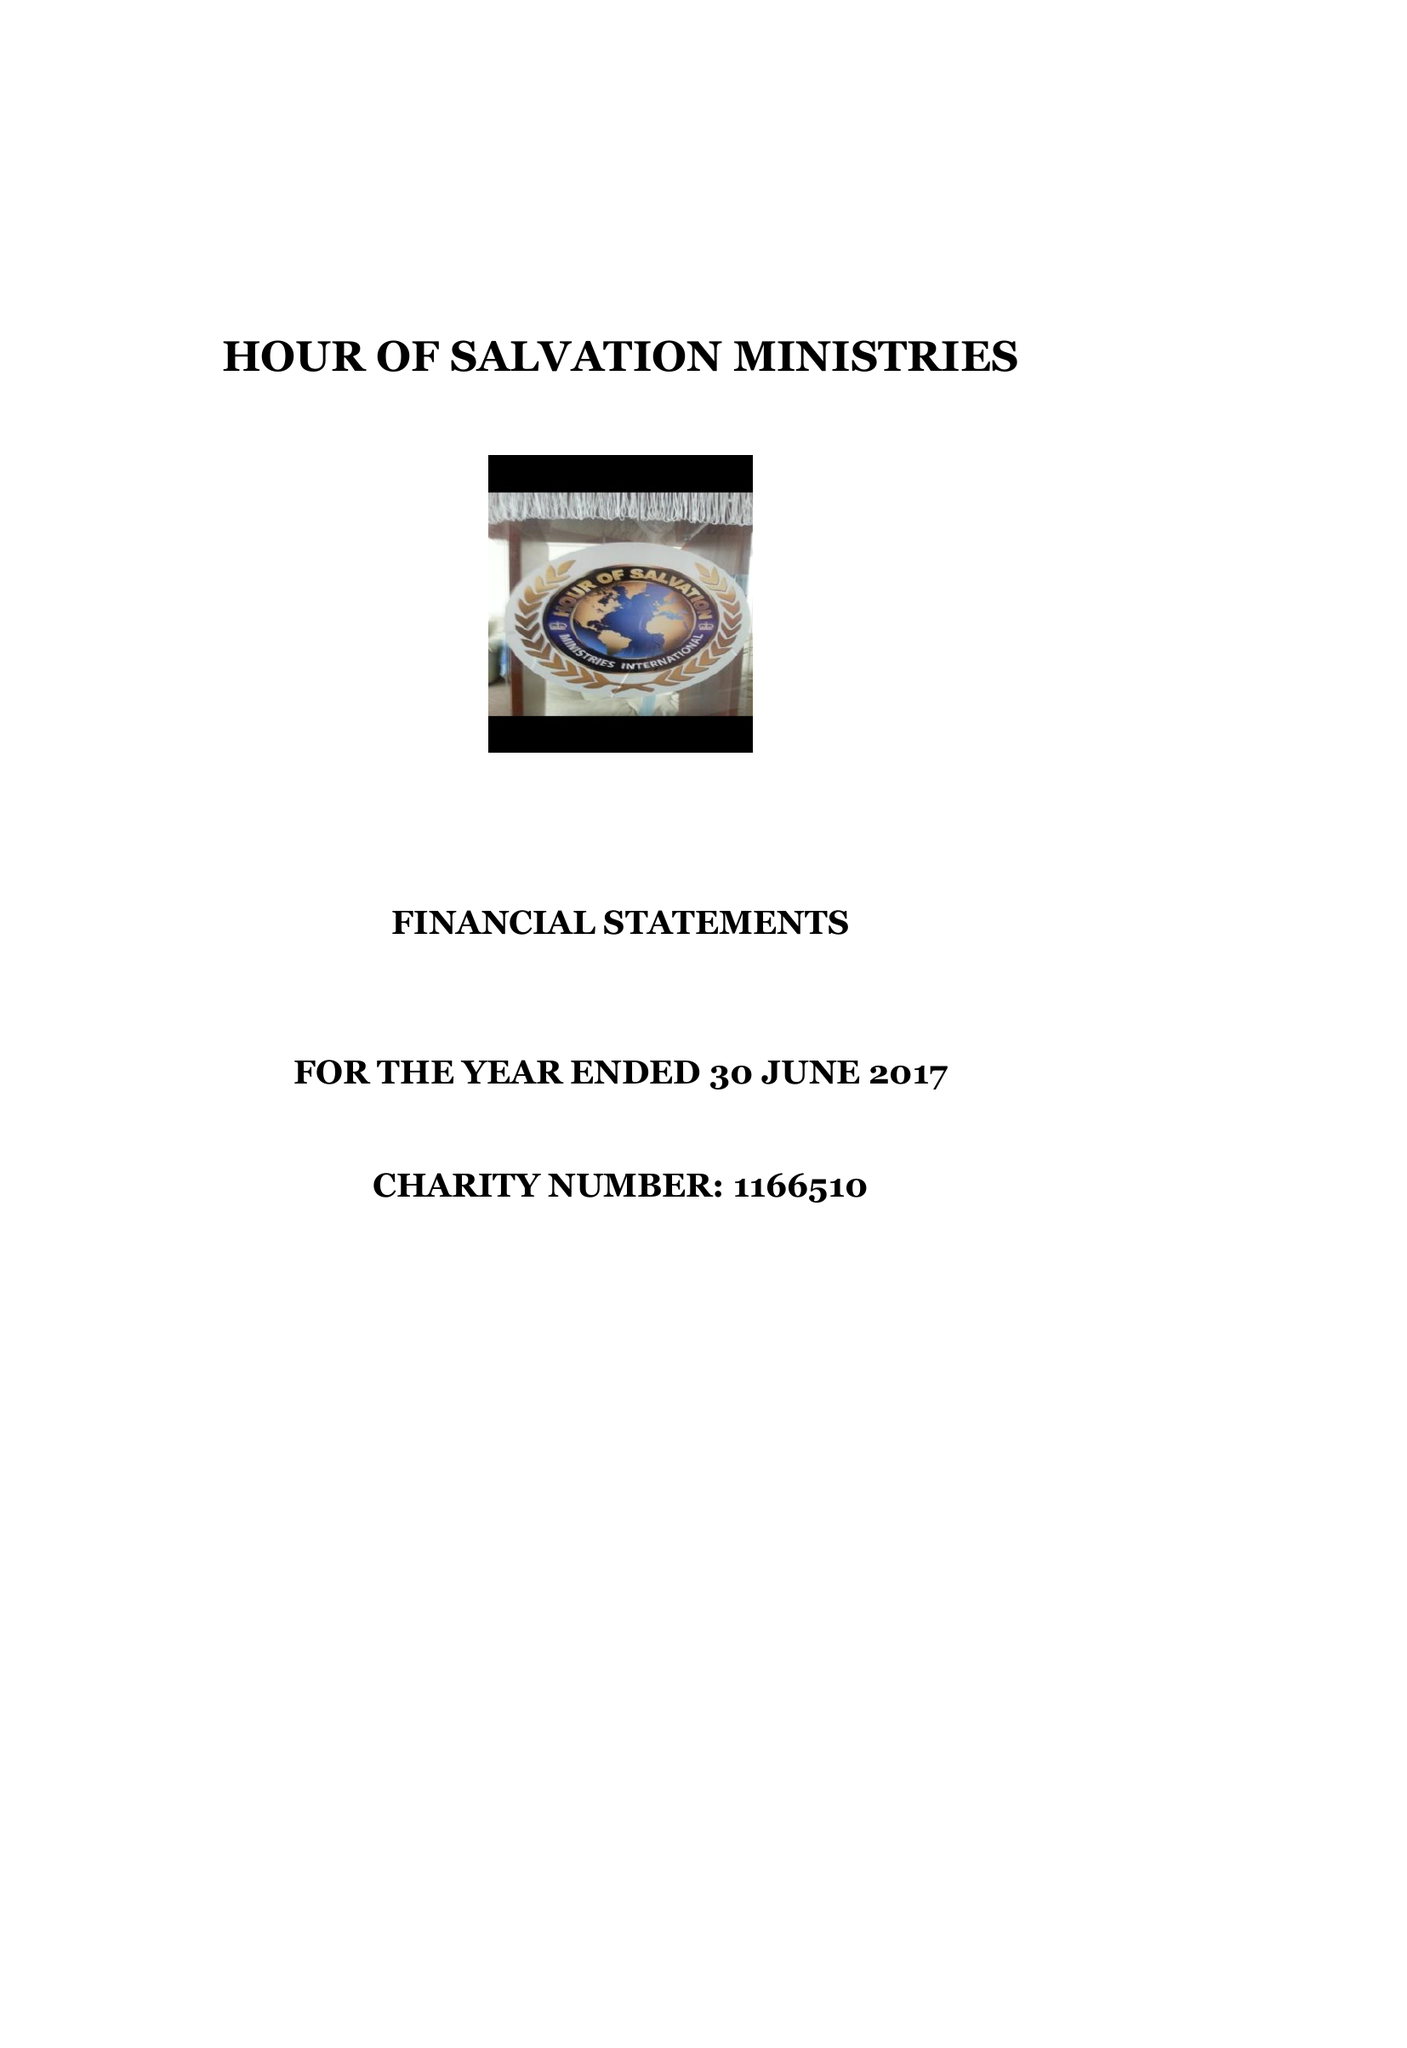What is the value for the address__post_town?
Answer the question using a single word or phrase. MILTON KEYNES 